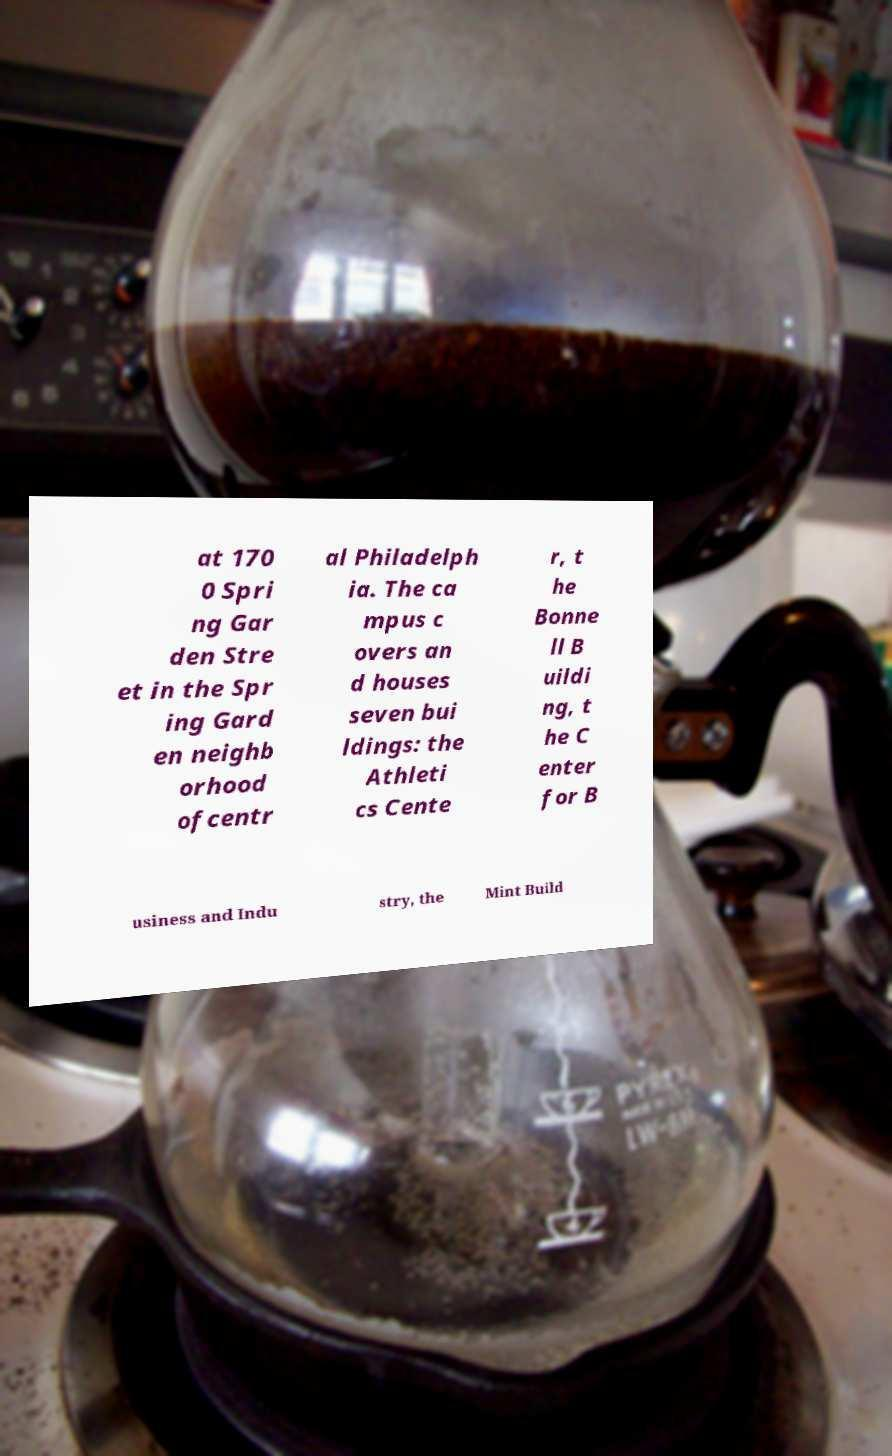Can you read and provide the text displayed in the image?This photo seems to have some interesting text. Can you extract and type it out for me? at 170 0 Spri ng Gar den Stre et in the Spr ing Gard en neighb orhood ofcentr al Philadelph ia. The ca mpus c overs an d houses seven bui ldings: the Athleti cs Cente r, t he Bonne ll B uildi ng, t he C enter for B usiness and Indu stry, the Mint Build 